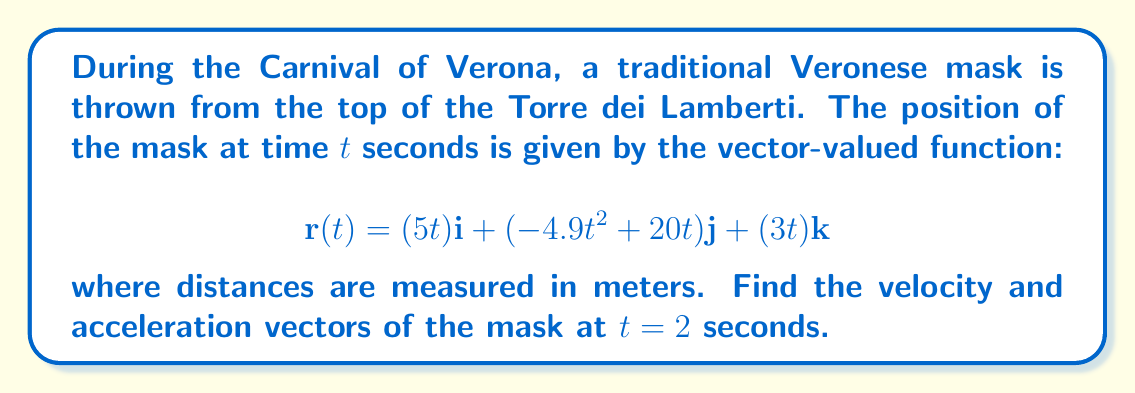Could you help me with this problem? To solve this problem, we need to find the first and second derivatives of the position function $\mathbf{r}(t)$.

1. Velocity vector:
The velocity vector $\mathbf{v}(t)$ is the first derivative of the position vector $\mathbf{r}(t)$.

$$\mathbf{v}(t) = \frac{d}{dt}\mathbf{r}(t) = \frac{d}{dt}(5t)\mathbf{i} + \frac{d}{dt}(-4.9t^2 + 20t)\mathbf{j} + \frac{d}{dt}(3t)\mathbf{k}$$

$$\mathbf{v}(t) = 5\mathbf{i} + (-9.8t + 20)\mathbf{j} + 3\mathbf{k}$$

At $t = 2$ seconds:

$$\mathbf{v}(2) = 5\mathbf{i} + (-9.8(2) + 20)\mathbf{j} + 3\mathbf{k} = 5\mathbf{i} + 0.4\mathbf{j} + 3\mathbf{k}$$

2. Acceleration vector:
The acceleration vector $\mathbf{a}(t)$ is the second derivative of the position vector $\mathbf{r}(t)$, or the first derivative of the velocity vector $\mathbf{v}(t)$.

$$\mathbf{a}(t) = \frac{d}{dt}\mathbf{v}(t) = \frac{d}{dt}(5)\mathbf{i} + \frac{d}{dt}(-9.8t + 20)\mathbf{j} + \frac{d}{dt}(3)\mathbf{k}$$

$$\mathbf{a}(t) = 0\mathbf{i} + (-9.8)\mathbf{j} + 0\mathbf{k}$$

The acceleration vector is constant and doesn't depend on time, so it's the same at $t = 2$ seconds:

$$\mathbf{a}(2) = 0\mathbf{i} + (-9.8)\mathbf{j} + 0\mathbf{k}$$
Answer: Velocity vector at $t = 2$ seconds: $\mathbf{v}(2) = 5\mathbf{i} + 0.4\mathbf{j} + 3\mathbf{k}$ m/s
Acceleration vector at $t = 2$ seconds: $\mathbf{a}(2) = 0\mathbf{i} + (-9.8)\mathbf{j} + 0\mathbf{k}$ m/s² 